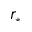Convert formula to latex. <formula><loc_0><loc_0><loc_500><loc_500>r _ { * }</formula> 